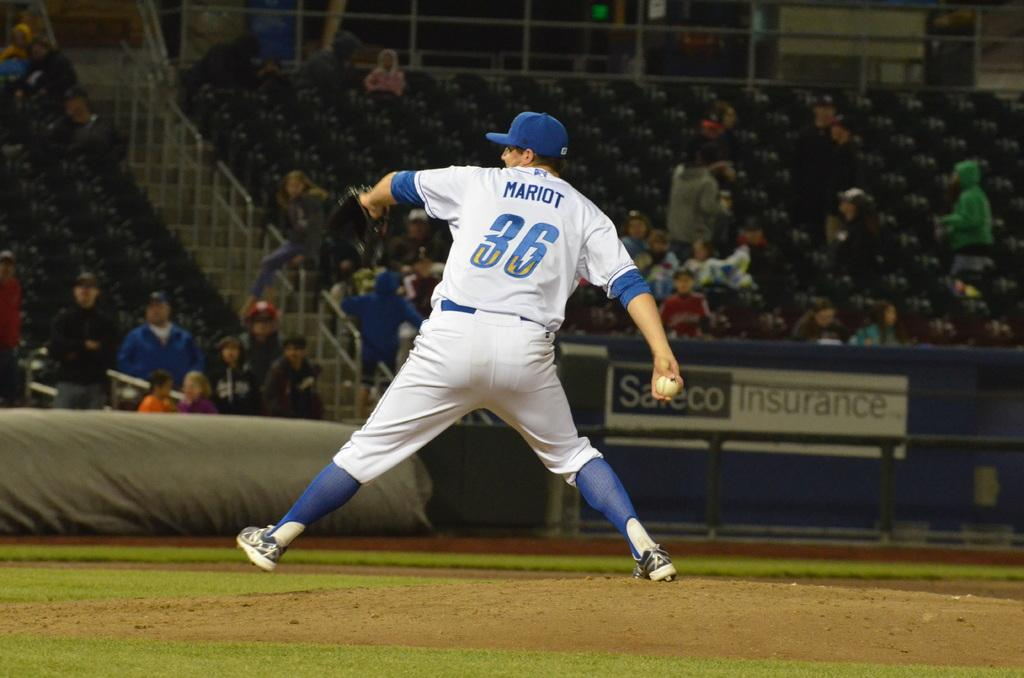Provide a one-sentence caption for the provided image. A baseball player with the number 36 and his name written on the back of his jersey getting ready to throw the ball. 